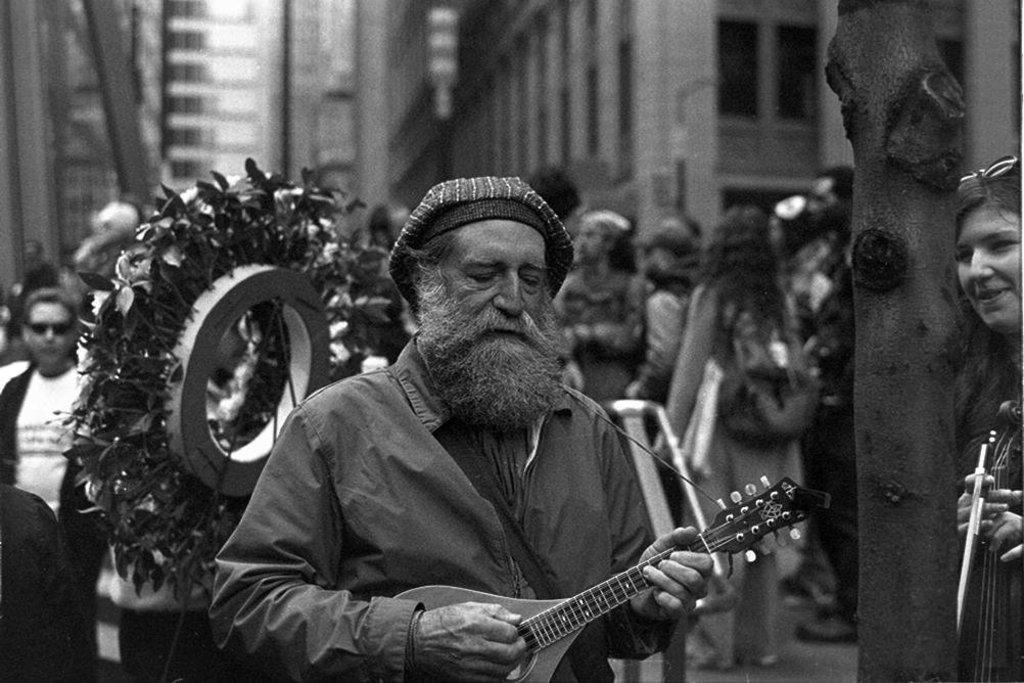How many people are visible in the image? There are people in the image, but the exact number is not specified. What are the two people in the front of the image doing? The two people in the front of the image are holding guitars. What can be seen in the background of the image? There are buildings in the background of the image. Can you see a donkey wearing lace in the image? No, there is no donkey or lace present in the image. 